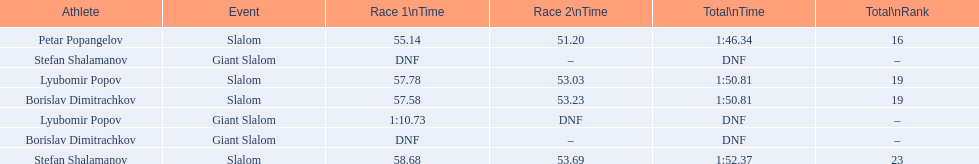What were the event names during bulgaria at the 1988 winter olympics? Stefan Shalamanov, Borislav Dimitrachkov, Lyubomir Popov. And which players participated at giant slalom? Giant Slalom, Giant Slalom, Giant Slalom, Slalom, Slalom, Slalom, Slalom. What were their race 1 times? DNF, DNF, 1:10.73. What was lyubomir popov's personal time? 1:10.73. 